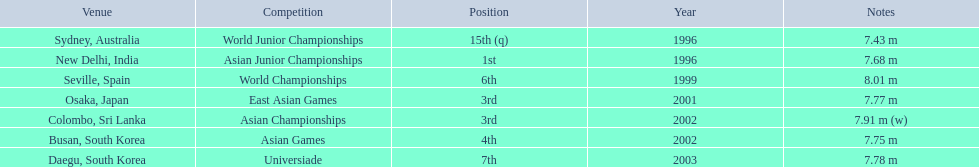Which competition did this person compete in immediately before the east asian games in 2001? World Championships. 